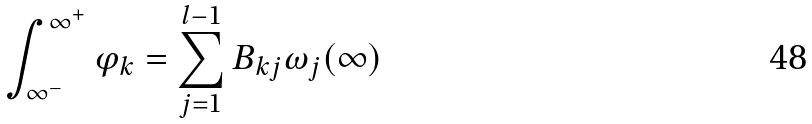<formula> <loc_0><loc_0><loc_500><loc_500>\int _ { \infty ^ { - } } ^ { \infty ^ { + } } { \varphi _ { k } } = \sum _ { j = 1 } ^ { l - 1 } B _ { k j } \omega _ { j } ( \infty )</formula> 